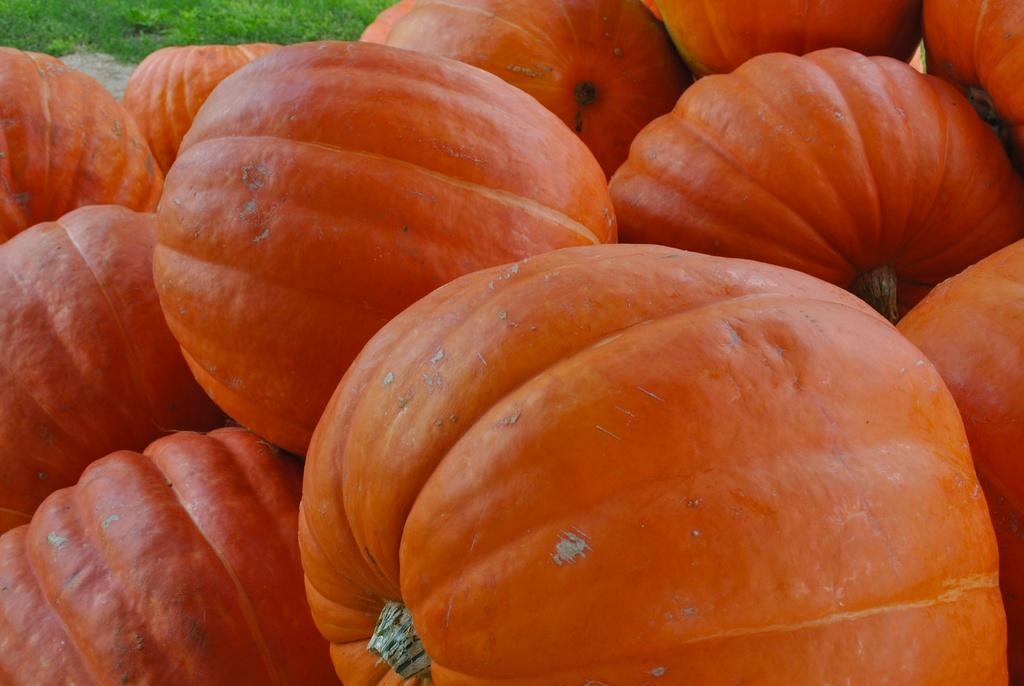What is the main subject of the image? The main subject of the subject of the image is a group of pumpkins. What type of vegetation can be seen in the image? There is grass visible at the top of the image. What type of division is taking place in the image? There is no division taking place in the image; it features a group of pumpkins and grass. What book can be seen on the pumpkins in the image? There is no book present in the image; it only features pumpkins and grass. 